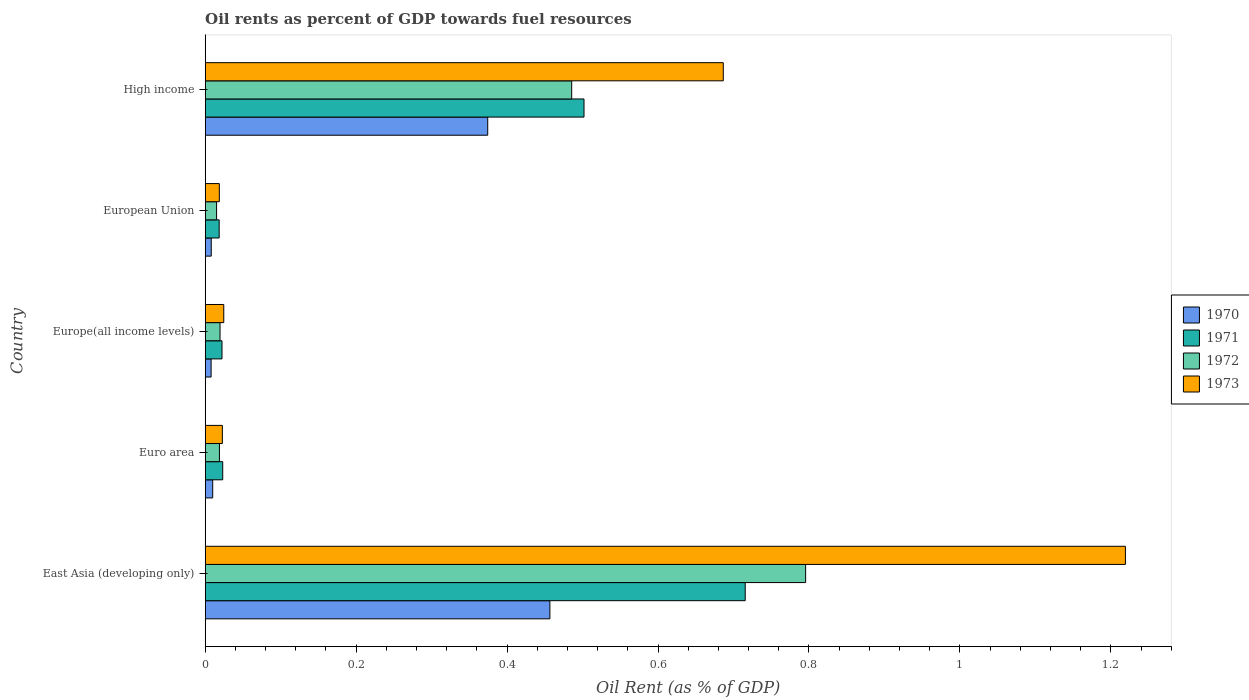How many different coloured bars are there?
Offer a very short reply. 4. How many bars are there on the 3rd tick from the top?
Keep it short and to the point. 4. How many bars are there on the 1st tick from the bottom?
Offer a very short reply. 4. What is the oil rent in 1973 in European Union?
Offer a very short reply. 0.02. Across all countries, what is the maximum oil rent in 1972?
Your answer should be compact. 0.8. Across all countries, what is the minimum oil rent in 1972?
Your answer should be very brief. 0.02. In which country was the oil rent in 1970 maximum?
Offer a very short reply. East Asia (developing only). In which country was the oil rent in 1970 minimum?
Your answer should be compact. Europe(all income levels). What is the total oil rent in 1971 in the graph?
Make the answer very short. 1.28. What is the difference between the oil rent in 1973 in East Asia (developing only) and that in High income?
Offer a very short reply. 0.53. What is the difference between the oil rent in 1972 in High income and the oil rent in 1971 in European Union?
Your response must be concise. 0.47. What is the average oil rent in 1971 per country?
Make the answer very short. 0.26. What is the difference between the oil rent in 1971 and oil rent in 1973 in Europe(all income levels)?
Provide a succinct answer. -0. What is the ratio of the oil rent in 1970 in Euro area to that in European Union?
Make the answer very short. 1.24. What is the difference between the highest and the second highest oil rent in 1972?
Make the answer very short. 0.31. What is the difference between the highest and the lowest oil rent in 1973?
Ensure brevity in your answer.  1.2. In how many countries, is the oil rent in 1972 greater than the average oil rent in 1972 taken over all countries?
Your response must be concise. 2. Is the sum of the oil rent in 1972 in Europe(all income levels) and High income greater than the maximum oil rent in 1971 across all countries?
Provide a short and direct response. No. What does the 4th bar from the top in European Union represents?
Offer a very short reply. 1970. What does the 4th bar from the bottom in Europe(all income levels) represents?
Your response must be concise. 1973. Does the graph contain any zero values?
Give a very brief answer. No. Does the graph contain grids?
Your answer should be compact. No. Where does the legend appear in the graph?
Ensure brevity in your answer.  Center right. How are the legend labels stacked?
Your answer should be very brief. Vertical. What is the title of the graph?
Offer a very short reply. Oil rents as percent of GDP towards fuel resources. Does "1960" appear as one of the legend labels in the graph?
Your answer should be very brief. No. What is the label or title of the X-axis?
Offer a very short reply. Oil Rent (as % of GDP). What is the Oil Rent (as % of GDP) in 1970 in East Asia (developing only)?
Make the answer very short. 0.46. What is the Oil Rent (as % of GDP) of 1971 in East Asia (developing only)?
Give a very brief answer. 0.72. What is the Oil Rent (as % of GDP) in 1972 in East Asia (developing only)?
Keep it short and to the point. 0.8. What is the Oil Rent (as % of GDP) in 1973 in East Asia (developing only)?
Give a very brief answer. 1.22. What is the Oil Rent (as % of GDP) of 1970 in Euro area?
Ensure brevity in your answer.  0.01. What is the Oil Rent (as % of GDP) in 1971 in Euro area?
Make the answer very short. 0.02. What is the Oil Rent (as % of GDP) in 1972 in Euro area?
Give a very brief answer. 0.02. What is the Oil Rent (as % of GDP) of 1973 in Euro area?
Your answer should be very brief. 0.02. What is the Oil Rent (as % of GDP) in 1970 in Europe(all income levels)?
Keep it short and to the point. 0.01. What is the Oil Rent (as % of GDP) in 1971 in Europe(all income levels)?
Offer a very short reply. 0.02. What is the Oil Rent (as % of GDP) of 1972 in Europe(all income levels)?
Provide a succinct answer. 0.02. What is the Oil Rent (as % of GDP) of 1973 in Europe(all income levels)?
Provide a succinct answer. 0.02. What is the Oil Rent (as % of GDP) of 1970 in European Union?
Your response must be concise. 0.01. What is the Oil Rent (as % of GDP) of 1971 in European Union?
Your answer should be compact. 0.02. What is the Oil Rent (as % of GDP) in 1972 in European Union?
Provide a short and direct response. 0.02. What is the Oil Rent (as % of GDP) in 1973 in European Union?
Your response must be concise. 0.02. What is the Oil Rent (as % of GDP) of 1970 in High income?
Make the answer very short. 0.37. What is the Oil Rent (as % of GDP) in 1971 in High income?
Keep it short and to the point. 0.5. What is the Oil Rent (as % of GDP) in 1972 in High income?
Ensure brevity in your answer.  0.49. What is the Oil Rent (as % of GDP) in 1973 in High income?
Give a very brief answer. 0.69. Across all countries, what is the maximum Oil Rent (as % of GDP) in 1970?
Give a very brief answer. 0.46. Across all countries, what is the maximum Oil Rent (as % of GDP) of 1971?
Your response must be concise. 0.72. Across all countries, what is the maximum Oil Rent (as % of GDP) of 1972?
Your answer should be compact. 0.8. Across all countries, what is the maximum Oil Rent (as % of GDP) of 1973?
Offer a terse response. 1.22. Across all countries, what is the minimum Oil Rent (as % of GDP) in 1970?
Keep it short and to the point. 0.01. Across all countries, what is the minimum Oil Rent (as % of GDP) of 1971?
Keep it short and to the point. 0.02. Across all countries, what is the minimum Oil Rent (as % of GDP) of 1972?
Ensure brevity in your answer.  0.02. Across all countries, what is the minimum Oil Rent (as % of GDP) of 1973?
Provide a succinct answer. 0.02. What is the total Oil Rent (as % of GDP) in 1970 in the graph?
Offer a very short reply. 0.86. What is the total Oil Rent (as % of GDP) of 1971 in the graph?
Your answer should be very brief. 1.28. What is the total Oil Rent (as % of GDP) of 1972 in the graph?
Your answer should be compact. 1.33. What is the total Oil Rent (as % of GDP) in 1973 in the graph?
Provide a short and direct response. 1.97. What is the difference between the Oil Rent (as % of GDP) in 1970 in East Asia (developing only) and that in Euro area?
Offer a terse response. 0.45. What is the difference between the Oil Rent (as % of GDP) of 1971 in East Asia (developing only) and that in Euro area?
Provide a short and direct response. 0.69. What is the difference between the Oil Rent (as % of GDP) in 1972 in East Asia (developing only) and that in Euro area?
Your answer should be very brief. 0.78. What is the difference between the Oil Rent (as % of GDP) of 1973 in East Asia (developing only) and that in Euro area?
Provide a short and direct response. 1.2. What is the difference between the Oil Rent (as % of GDP) in 1970 in East Asia (developing only) and that in Europe(all income levels)?
Provide a short and direct response. 0.45. What is the difference between the Oil Rent (as % of GDP) of 1971 in East Asia (developing only) and that in Europe(all income levels)?
Your answer should be very brief. 0.69. What is the difference between the Oil Rent (as % of GDP) in 1972 in East Asia (developing only) and that in Europe(all income levels)?
Ensure brevity in your answer.  0.78. What is the difference between the Oil Rent (as % of GDP) in 1973 in East Asia (developing only) and that in Europe(all income levels)?
Provide a short and direct response. 1.19. What is the difference between the Oil Rent (as % of GDP) of 1970 in East Asia (developing only) and that in European Union?
Your answer should be compact. 0.45. What is the difference between the Oil Rent (as % of GDP) in 1971 in East Asia (developing only) and that in European Union?
Keep it short and to the point. 0.7. What is the difference between the Oil Rent (as % of GDP) of 1972 in East Asia (developing only) and that in European Union?
Your response must be concise. 0.78. What is the difference between the Oil Rent (as % of GDP) in 1973 in East Asia (developing only) and that in European Union?
Provide a succinct answer. 1.2. What is the difference between the Oil Rent (as % of GDP) in 1970 in East Asia (developing only) and that in High income?
Your answer should be very brief. 0.08. What is the difference between the Oil Rent (as % of GDP) in 1971 in East Asia (developing only) and that in High income?
Offer a very short reply. 0.21. What is the difference between the Oil Rent (as % of GDP) in 1972 in East Asia (developing only) and that in High income?
Provide a succinct answer. 0.31. What is the difference between the Oil Rent (as % of GDP) of 1973 in East Asia (developing only) and that in High income?
Keep it short and to the point. 0.53. What is the difference between the Oil Rent (as % of GDP) of 1970 in Euro area and that in Europe(all income levels)?
Your answer should be very brief. 0. What is the difference between the Oil Rent (as % of GDP) in 1971 in Euro area and that in Europe(all income levels)?
Give a very brief answer. 0. What is the difference between the Oil Rent (as % of GDP) in 1972 in Euro area and that in Europe(all income levels)?
Ensure brevity in your answer.  -0. What is the difference between the Oil Rent (as % of GDP) of 1973 in Euro area and that in Europe(all income levels)?
Your answer should be compact. -0. What is the difference between the Oil Rent (as % of GDP) in 1970 in Euro area and that in European Union?
Your answer should be very brief. 0. What is the difference between the Oil Rent (as % of GDP) in 1971 in Euro area and that in European Union?
Provide a short and direct response. 0. What is the difference between the Oil Rent (as % of GDP) of 1972 in Euro area and that in European Union?
Offer a terse response. 0. What is the difference between the Oil Rent (as % of GDP) of 1973 in Euro area and that in European Union?
Your answer should be very brief. 0. What is the difference between the Oil Rent (as % of GDP) of 1970 in Euro area and that in High income?
Provide a succinct answer. -0.36. What is the difference between the Oil Rent (as % of GDP) in 1971 in Euro area and that in High income?
Offer a very short reply. -0.48. What is the difference between the Oil Rent (as % of GDP) in 1972 in Euro area and that in High income?
Offer a terse response. -0.47. What is the difference between the Oil Rent (as % of GDP) in 1973 in Euro area and that in High income?
Ensure brevity in your answer.  -0.66. What is the difference between the Oil Rent (as % of GDP) of 1970 in Europe(all income levels) and that in European Union?
Your answer should be compact. -0. What is the difference between the Oil Rent (as % of GDP) in 1971 in Europe(all income levels) and that in European Union?
Give a very brief answer. 0. What is the difference between the Oil Rent (as % of GDP) of 1972 in Europe(all income levels) and that in European Union?
Your response must be concise. 0. What is the difference between the Oil Rent (as % of GDP) in 1973 in Europe(all income levels) and that in European Union?
Offer a very short reply. 0.01. What is the difference between the Oil Rent (as % of GDP) in 1970 in Europe(all income levels) and that in High income?
Provide a short and direct response. -0.37. What is the difference between the Oil Rent (as % of GDP) of 1971 in Europe(all income levels) and that in High income?
Make the answer very short. -0.48. What is the difference between the Oil Rent (as % of GDP) in 1972 in Europe(all income levels) and that in High income?
Make the answer very short. -0.47. What is the difference between the Oil Rent (as % of GDP) in 1973 in Europe(all income levels) and that in High income?
Provide a short and direct response. -0.66. What is the difference between the Oil Rent (as % of GDP) in 1970 in European Union and that in High income?
Ensure brevity in your answer.  -0.37. What is the difference between the Oil Rent (as % of GDP) in 1971 in European Union and that in High income?
Offer a very short reply. -0.48. What is the difference between the Oil Rent (as % of GDP) in 1972 in European Union and that in High income?
Offer a terse response. -0.47. What is the difference between the Oil Rent (as % of GDP) in 1973 in European Union and that in High income?
Keep it short and to the point. -0.67. What is the difference between the Oil Rent (as % of GDP) in 1970 in East Asia (developing only) and the Oil Rent (as % of GDP) in 1971 in Euro area?
Your response must be concise. 0.43. What is the difference between the Oil Rent (as % of GDP) in 1970 in East Asia (developing only) and the Oil Rent (as % of GDP) in 1972 in Euro area?
Keep it short and to the point. 0.44. What is the difference between the Oil Rent (as % of GDP) in 1970 in East Asia (developing only) and the Oil Rent (as % of GDP) in 1973 in Euro area?
Your answer should be very brief. 0.43. What is the difference between the Oil Rent (as % of GDP) of 1971 in East Asia (developing only) and the Oil Rent (as % of GDP) of 1972 in Euro area?
Your response must be concise. 0.7. What is the difference between the Oil Rent (as % of GDP) of 1971 in East Asia (developing only) and the Oil Rent (as % of GDP) of 1973 in Euro area?
Keep it short and to the point. 0.69. What is the difference between the Oil Rent (as % of GDP) of 1972 in East Asia (developing only) and the Oil Rent (as % of GDP) of 1973 in Euro area?
Make the answer very short. 0.77. What is the difference between the Oil Rent (as % of GDP) in 1970 in East Asia (developing only) and the Oil Rent (as % of GDP) in 1971 in Europe(all income levels)?
Your answer should be compact. 0.43. What is the difference between the Oil Rent (as % of GDP) in 1970 in East Asia (developing only) and the Oil Rent (as % of GDP) in 1972 in Europe(all income levels)?
Your response must be concise. 0.44. What is the difference between the Oil Rent (as % of GDP) of 1970 in East Asia (developing only) and the Oil Rent (as % of GDP) of 1973 in Europe(all income levels)?
Provide a short and direct response. 0.43. What is the difference between the Oil Rent (as % of GDP) in 1971 in East Asia (developing only) and the Oil Rent (as % of GDP) in 1972 in Europe(all income levels)?
Your response must be concise. 0.7. What is the difference between the Oil Rent (as % of GDP) in 1971 in East Asia (developing only) and the Oil Rent (as % of GDP) in 1973 in Europe(all income levels)?
Your response must be concise. 0.69. What is the difference between the Oil Rent (as % of GDP) of 1972 in East Asia (developing only) and the Oil Rent (as % of GDP) of 1973 in Europe(all income levels)?
Make the answer very short. 0.77. What is the difference between the Oil Rent (as % of GDP) in 1970 in East Asia (developing only) and the Oil Rent (as % of GDP) in 1971 in European Union?
Give a very brief answer. 0.44. What is the difference between the Oil Rent (as % of GDP) in 1970 in East Asia (developing only) and the Oil Rent (as % of GDP) in 1972 in European Union?
Your answer should be compact. 0.44. What is the difference between the Oil Rent (as % of GDP) of 1970 in East Asia (developing only) and the Oil Rent (as % of GDP) of 1973 in European Union?
Keep it short and to the point. 0.44. What is the difference between the Oil Rent (as % of GDP) of 1971 in East Asia (developing only) and the Oil Rent (as % of GDP) of 1972 in European Union?
Make the answer very short. 0.7. What is the difference between the Oil Rent (as % of GDP) in 1971 in East Asia (developing only) and the Oil Rent (as % of GDP) in 1973 in European Union?
Provide a short and direct response. 0.7. What is the difference between the Oil Rent (as % of GDP) of 1972 in East Asia (developing only) and the Oil Rent (as % of GDP) of 1973 in European Union?
Offer a terse response. 0.78. What is the difference between the Oil Rent (as % of GDP) of 1970 in East Asia (developing only) and the Oil Rent (as % of GDP) of 1971 in High income?
Offer a terse response. -0.05. What is the difference between the Oil Rent (as % of GDP) of 1970 in East Asia (developing only) and the Oil Rent (as % of GDP) of 1972 in High income?
Your response must be concise. -0.03. What is the difference between the Oil Rent (as % of GDP) of 1970 in East Asia (developing only) and the Oil Rent (as % of GDP) of 1973 in High income?
Offer a very short reply. -0.23. What is the difference between the Oil Rent (as % of GDP) in 1971 in East Asia (developing only) and the Oil Rent (as % of GDP) in 1972 in High income?
Your response must be concise. 0.23. What is the difference between the Oil Rent (as % of GDP) in 1971 in East Asia (developing only) and the Oil Rent (as % of GDP) in 1973 in High income?
Provide a succinct answer. 0.03. What is the difference between the Oil Rent (as % of GDP) in 1972 in East Asia (developing only) and the Oil Rent (as % of GDP) in 1973 in High income?
Offer a terse response. 0.11. What is the difference between the Oil Rent (as % of GDP) in 1970 in Euro area and the Oil Rent (as % of GDP) in 1971 in Europe(all income levels)?
Your response must be concise. -0.01. What is the difference between the Oil Rent (as % of GDP) of 1970 in Euro area and the Oil Rent (as % of GDP) of 1972 in Europe(all income levels)?
Ensure brevity in your answer.  -0.01. What is the difference between the Oil Rent (as % of GDP) of 1970 in Euro area and the Oil Rent (as % of GDP) of 1973 in Europe(all income levels)?
Keep it short and to the point. -0.01. What is the difference between the Oil Rent (as % of GDP) in 1971 in Euro area and the Oil Rent (as % of GDP) in 1972 in Europe(all income levels)?
Ensure brevity in your answer.  0. What is the difference between the Oil Rent (as % of GDP) in 1971 in Euro area and the Oil Rent (as % of GDP) in 1973 in Europe(all income levels)?
Provide a succinct answer. -0. What is the difference between the Oil Rent (as % of GDP) in 1972 in Euro area and the Oil Rent (as % of GDP) in 1973 in Europe(all income levels)?
Your response must be concise. -0.01. What is the difference between the Oil Rent (as % of GDP) in 1970 in Euro area and the Oil Rent (as % of GDP) in 1971 in European Union?
Your answer should be compact. -0.01. What is the difference between the Oil Rent (as % of GDP) in 1970 in Euro area and the Oil Rent (as % of GDP) in 1972 in European Union?
Keep it short and to the point. -0.01. What is the difference between the Oil Rent (as % of GDP) in 1970 in Euro area and the Oil Rent (as % of GDP) in 1973 in European Union?
Offer a terse response. -0.01. What is the difference between the Oil Rent (as % of GDP) of 1971 in Euro area and the Oil Rent (as % of GDP) of 1972 in European Union?
Your answer should be compact. 0.01. What is the difference between the Oil Rent (as % of GDP) of 1971 in Euro area and the Oil Rent (as % of GDP) of 1973 in European Union?
Make the answer very short. 0. What is the difference between the Oil Rent (as % of GDP) of 1972 in Euro area and the Oil Rent (as % of GDP) of 1973 in European Union?
Your response must be concise. 0. What is the difference between the Oil Rent (as % of GDP) in 1970 in Euro area and the Oil Rent (as % of GDP) in 1971 in High income?
Make the answer very short. -0.49. What is the difference between the Oil Rent (as % of GDP) in 1970 in Euro area and the Oil Rent (as % of GDP) in 1972 in High income?
Give a very brief answer. -0.48. What is the difference between the Oil Rent (as % of GDP) of 1970 in Euro area and the Oil Rent (as % of GDP) of 1973 in High income?
Keep it short and to the point. -0.68. What is the difference between the Oil Rent (as % of GDP) of 1971 in Euro area and the Oil Rent (as % of GDP) of 1972 in High income?
Offer a terse response. -0.46. What is the difference between the Oil Rent (as % of GDP) in 1971 in Euro area and the Oil Rent (as % of GDP) in 1973 in High income?
Your answer should be very brief. -0.66. What is the difference between the Oil Rent (as % of GDP) of 1972 in Euro area and the Oil Rent (as % of GDP) of 1973 in High income?
Your answer should be compact. -0.67. What is the difference between the Oil Rent (as % of GDP) of 1970 in Europe(all income levels) and the Oil Rent (as % of GDP) of 1971 in European Union?
Ensure brevity in your answer.  -0.01. What is the difference between the Oil Rent (as % of GDP) of 1970 in Europe(all income levels) and the Oil Rent (as % of GDP) of 1972 in European Union?
Give a very brief answer. -0.01. What is the difference between the Oil Rent (as % of GDP) in 1970 in Europe(all income levels) and the Oil Rent (as % of GDP) in 1973 in European Union?
Make the answer very short. -0.01. What is the difference between the Oil Rent (as % of GDP) of 1971 in Europe(all income levels) and the Oil Rent (as % of GDP) of 1972 in European Union?
Your answer should be very brief. 0.01. What is the difference between the Oil Rent (as % of GDP) in 1971 in Europe(all income levels) and the Oil Rent (as % of GDP) in 1973 in European Union?
Give a very brief answer. 0. What is the difference between the Oil Rent (as % of GDP) in 1972 in Europe(all income levels) and the Oil Rent (as % of GDP) in 1973 in European Union?
Your answer should be compact. 0. What is the difference between the Oil Rent (as % of GDP) in 1970 in Europe(all income levels) and the Oil Rent (as % of GDP) in 1971 in High income?
Offer a terse response. -0.49. What is the difference between the Oil Rent (as % of GDP) in 1970 in Europe(all income levels) and the Oil Rent (as % of GDP) in 1972 in High income?
Your response must be concise. -0.48. What is the difference between the Oil Rent (as % of GDP) of 1970 in Europe(all income levels) and the Oil Rent (as % of GDP) of 1973 in High income?
Make the answer very short. -0.68. What is the difference between the Oil Rent (as % of GDP) of 1971 in Europe(all income levels) and the Oil Rent (as % of GDP) of 1972 in High income?
Offer a terse response. -0.46. What is the difference between the Oil Rent (as % of GDP) in 1971 in Europe(all income levels) and the Oil Rent (as % of GDP) in 1973 in High income?
Make the answer very short. -0.66. What is the difference between the Oil Rent (as % of GDP) in 1972 in Europe(all income levels) and the Oil Rent (as % of GDP) in 1973 in High income?
Give a very brief answer. -0.67. What is the difference between the Oil Rent (as % of GDP) of 1970 in European Union and the Oil Rent (as % of GDP) of 1971 in High income?
Your response must be concise. -0.49. What is the difference between the Oil Rent (as % of GDP) in 1970 in European Union and the Oil Rent (as % of GDP) in 1972 in High income?
Your answer should be compact. -0.48. What is the difference between the Oil Rent (as % of GDP) of 1970 in European Union and the Oil Rent (as % of GDP) of 1973 in High income?
Provide a short and direct response. -0.68. What is the difference between the Oil Rent (as % of GDP) of 1971 in European Union and the Oil Rent (as % of GDP) of 1972 in High income?
Your response must be concise. -0.47. What is the difference between the Oil Rent (as % of GDP) in 1971 in European Union and the Oil Rent (as % of GDP) in 1973 in High income?
Offer a terse response. -0.67. What is the difference between the Oil Rent (as % of GDP) of 1972 in European Union and the Oil Rent (as % of GDP) of 1973 in High income?
Provide a short and direct response. -0.67. What is the average Oil Rent (as % of GDP) in 1970 per country?
Make the answer very short. 0.17. What is the average Oil Rent (as % of GDP) in 1971 per country?
Your answer should be compact. 0.26. What is the average Oil Rent (as % of GDP) of 1972 per country?
Give a very brief answer. 0.27. What is the average Oil Rent (as % of GDP) of 1973 per country?
Provide a short and direct response. 0.39. What is the difference between the Oil Rent (as % of GDP) of 1970 and Oil Rent (as % of GDP) of 1971 in East Asia (developing only)?
Your answer should be very brief. -0.26. What is the difference between the Oil Rent (as % of GDP) in 1970 and Oil Rent (as % of GDP) in 1972 in East Asia (developing only)?
Your answer should be compact. -0.34. What is the difference between the Oil Rent (as % of GDP) of 1970 and Oil Rent (as % of GDP) of 1973 in East Asia (developing only)?
Offer a very short reply. -0.76. What is the difference between the Oil Rent (as % of GDP) of 1971 and Oil Rent (as % of GDP) of 1972 in East Asia (developing only)?
Offer a very short reply. -0.08. What is the difference between the Oil Rent (as % of GDP) in 1971 and Oil Rent (as % of GDP) in 1973 in East Asia (developing only)?
Keep it short and to the point. -0.5. What is the difference between the Oil Rent (as % of GDP) in 1972 and Oil Rent (as % of GDP) in 1973 in East Asia (developing only)?
Make the answer very short. -0.42. What is the difference between the Oil Rent (as % of GDP) in 1970 and Oil Rent (as % of GDP) in 1971 in Euro area?
Your answer should be very brief. -0.01. What is the difference between the Oil Rent (as % of GDP) of 1970 and Oil Rent (as % of GDP) of 1972 in Euro area?
Offer a terse response. -0.01. What is the difference between the Oil Rent (as % of GDP) in 1970 and Oil Rent (as % of GDP) in 1973 in Euro area?
Your answer should be very brief. -0.01. What is the difference between the Oil Rent (as % of GDP) of 1971 and Oil Rent (as % of GDP) of 1972 in Euro area?
Provide a short and direct response. 0. What is the difference between the Oil Rent (as % of GDP) in 1971 and Oil Rent (as % of GDP) in 1973 in Euro area?
Your answer should be very brief. 0. What is the difference between the Oil Rent (as % of GDP) of 1972 and Oil Rent (as % of GDP) of 1973 in Euro area?
Provide a short and direct response. -0. What is the difference between the Oil Rent (as % of GDP) in 1970 and Oil Rent (as % of GDP) in 1971 in Europe(all income levels)?
Your answer should be compact. -0.01. What is the difference between the Oil Rent (as % of GDP) in 1970 and Oil Rent (as % of GDP) in 1972 in Europe(all income levels)?
Keep it short and to the point. -0.01. What is the difference between the Oil Rent (as % of GDP) of 1970 and Oil Rent (as % of GDP) of 1973 in Europe(all income levels)?
Ensure brevity in your answer.  -0.02. What is the difference between the Oil Rent (as % of GDP) in 1971 and Oil Rent (as % of GDP) in 1972 in Europe(all income levels)?
Your response must be concise. 0. What is the difference between the Oil Rent (as % of GDP) of 1971 and Oil Rent (as % of GDP) of 1973 in Europe(all income levels)?
Your answer should be compact. -0. What is the difference between the Oil Rent (as % of GDP) of 1972 and Oil Rent (as % of GDP) of 1973 in Europe(all income levels)?
Ensure brevity in your answer.  -0.01. What is the difference between the Oil Rent (as % of GDP) in 1970 and Oil Rent (as % of GDP) in 1971 in European Union?
Ensure brevity in your answer.  -0.01. What is the difference between the Oil Rent (as % of GDP) of 1970 and Oil Rent (as % of GDP) of 1972 in European Union?
Keep it short and to the point. -0.01. What is the difference between the Oil Rent (as % of GDP) of 1970 and Oil Rent (as % of GDP) of 1973 in European Union?
Make the answer very short. -0.01. What is the difference between the Oil Rent (as % of GDP) of 1971 and Oil Rent (as % of GDP) of 1972 in European Union?
Your answer should be compact. 0. What is the difference between the Oil Rent (as % of GDP) in 1971 and Oil Rent (as % of GDP) in 1973 in European Union?
Provide a succinct answer. -0. What is the difference between the Oil Rent (as % of GDP) of 1972 and Oil Rent (as % of GDP) of 1973 in European Union?
Ensure brevity in your answer.  -0. What is the difference between the Oil Rent (as % of GDP) in 1970 and Oil Rent (as % of GDP) in 1971 in High income?
Keep it short and to the point. -0.13. What is the difference between the Oil Rent (as % of GDP) of 1970 and Oil Rent (as % of GDP) of 1972 in High income?
Your answer should be very brief. -0.11. What is the difference between the Oil Rent (as % of GDP) of 1970 and Oil Rent (as % of GDP) of 1973 in High income?
Ensure brevity in your answer.  -0.31. What is the difference between the Oil Rent (as % of GDP) of 1971 and Oil Rent (as % of GDP) of 1972 in High income?
Offer a very short reply. 0.02. What is the difference between the Oil Rent (as % of GDP) in 1971 and Oil Rent (as % of GDP) in 1973 in High income?
Make the answer very short. -0.18. What is the difference between the Oil Rent (as % of GDP) in 1972 and Oil Rent (as % of GDP) in 1973 in High income?
Make the answer very short. -0.2. What is the ratio of the Oil Rent (as % of GDP) in 1970 in East Asia (developing only) to that in Euro area?
Provide a short and direct response. 45.91. What is the ratio of the Oil Rent (as % of GDP) in 1971 in East Asia (developing only) to that in Euro area?
Your answer should be very brief. 30.82. What is the ratio of the Oil Rent (as % of GDP) in 1972 in East Asia (developing only) to that in Euro area?
Your answer should be very brief. 42.15. What is the ratio of the Oil Rent (as % of GDP) of 1973 in East Asia (developing only) to that in Euro area?
Your response must be concise. 53.59. What is the ratio of the Oil Rent (as % of GDP) in 1970 in East Asia (developing only) to that in Europe(all income levels)?
Offer a terse response. 58.27. What is the ratio of the Oil Rent (as % of GDP) in 1971 in East Asia (developing only) to that in Europe(all income levels)?
Your answer should be very brief. 32.13. What is the ratio of the Oil Rent (as % of GDP) in 1972 in East Asia (developing only) to that in Europe(all income levels)?
Your response must be concise. 40.49. What is the ratio of the Oil Rent (as % of GDP) in 1973 in East Asia (developing only) to that in Europe(all income levels)?
Your answer should be very brief. 49.55. What is the ratio of the Oil Rent (as % of GDP) of 1970 in East Asia (developing only) to that in European Union?
Your response must be concise. 57.01. What is the ratio of the Oil Rent (as % of GDP) in 1971 in East Asia (developing only) to that in European Union?
Provide a short and direct response. 38.65. What is the ratio of the Oil Rent (as % of GDP) of 1972 in East Asia (developing only) to that in European Union?
Make the answer very short. 52.73. What is the ratio of the Oil Rent (as % of GDP) in 1973 in East Asia (developing only) to that in European Union?
Your answer should be compact. 65.13. What is the ratio of the Oil Rent (as % of GDP) of 1970 in East Asia (developing only) to that in High income?
Ensure brevity in your answer.  1.22. What is the ratio of the Oil Rent (as % of GDP) of 1971 in East Asia (developing only) to that in High income?
Your answer should be very brief. 1.43. What is the ratio of the Oil Rent (as % of GDP) of 1972 in East Asia (developing only) to that in High income?
Your answer should be very brief. 1.64. What is the ratio of the Oil Rent (as % of GDP) of 1973 in East Asia (developing only) to that in High income?
Make the answer very short. 1.78. What is the ratio of the Oil Rent (as % of GDP) in 1970 in Euro area to that in Europe(all income levels)?
Your response must be concise. 1.27. What is the ratio of the Oil Rent (as % of GDP) in 1971 in Euro area to that in Europe(all income levels)?
Keep it short and to the point. 1.04. What is the ratio of the Oil Rent (as % of GDP) in 1972 in Euro area to that in Europe(all income levels)?
Offer a very short reply. 0.96. What is the ratio of the Oil Rent (as % of GDP) of 1973 in Euro area to that in Europe(all income levels)?
Provide a short and direct response. 0.92. What is the ratio of the Oil Rent (as % of GDP) in 1970 in Euro area to that in European Union?
Your response must be concise. 1.24. What is the ratio of the Oil Rent (as % of GDP) in 1971 in Euro area to that in European Union?
Your answer should be compact. 1.25. What is the ratio of the Oil Rent (as % of GDP) in 1972 in Euro area to that in European Union?
Offer a very short reply. 1.25. What is the ratio of the Oil Rent (as % of GDP) in 1973 in Euro area to that in European Union?
Keep it short and to the point. 1.22. What is the ratio of the Oil Rent (as % of GDP) of 1970 in Euro area to that in High income?
Offer a very short reply. 0.03. What is the ratio of the Oil Rent (as % of GDP) of 1971 in Euro area to that in High income?
Provide a short and direct response. 0.05. What is the ratio of the Oil Rent (as % of GDP) in 1972 in Euro area to that in High income?
Provide a succinct answer. 0.04. What is the ratio of the Oil Rent (as % of GDP) of 1973 in Euro area to that in High income?
Make the answer very short. 0.03. What is the ratio of the Oil Rent (as % of GDP) in 1970 in Europe(all income levels) to that in European Union?
Keep it short and to the point. 0.98. What is the ratio of the Oil Rent (as % of GDP) of 1971 in Europe(all income levels) to that in European Union?
Your answer should be compact. 1.2. What is the ratio of the Oil Rent (as % of GDP) in 1972 in Europe(all income levels) to that in European Union?
Provide a succinct answer. 1.3. What is the ratio of the Oil Rent (as % of GDP) in 1973 in Europe(all income levels) to that in European Union?
Your response must be concise. 1.31. What is the ratio of the Oil Rent (as % of GDP) of 1970 in Europe(all income levels) to that in High income?
Provide a succinct answer. 0.02. What is the ratio of the Oil Rent (as % of GDP) in 1971 in Europe(all income levels) to that in High income?
Keep it short and to the point. 0.04. What is the ratio of the Oil Rent (as % of GDP) in 1972 in Europe(all income levels) to that in High income?
Provide a succinct answer. 0.04. What is the ratio of the Oil Rent (as % of GDP) in 1973 in Europe(all income levels) to that in High income?
Your answer should be very brief. 0.04. What is the ratio of the Oil Rent (as % of GDP) in 1970 in European Union to that in High income?
Provide a succinct answer. 0.02. What is the ratio of the Oil Rent (as % of GDP) of 1971 in European Union to that in High income?
Your answer should be compact. 0.04. What is the ratio of the Oil Rent (as % of GDP) in 1972 in European Union to that in High income?
Keep it short and to the point. 0.03. What is the ratio of the Oil Rent (as % of GDP) in 1973 in European Union to that in High income?
Provide a succinct answer. 0.03. What is the difference between the highest and the second highest Oil Rent (as % of GDP) in 1970?
Keep it short and to the point. 0.08. What is the difference between the highest and the second highest Oil Rent (as % of GDP) of 1971?
Ensure brevity in your answer.  0.21. What is the difference between the highest and the second highest Oil Rent (as % of GDP) of 1972?
Provide a short and direct response. 0.31. What is the difference between the highest and the second highest Oil Rent (as % of GDP) in 1973?
Give a very brief answer. 0.53. What is the difference between the highest and the lowest Oil Rent (as % of GDP) in 1970?
Ensure brevity in your answer.  0.45. What is the difference between the highest and the lowest Oil Rent (as % of GDP) in 1971?
Your answer should be compact. 0.7. What is the difference between the highest and the lowest Oil Rent (as % of GDP) in 1972?
Keep it short and to the point. 0.78. What is the difference between the highest and the lowest Oil Rent (as % of GDP) of 1973?
Provide a succinct answer. 1.2. 